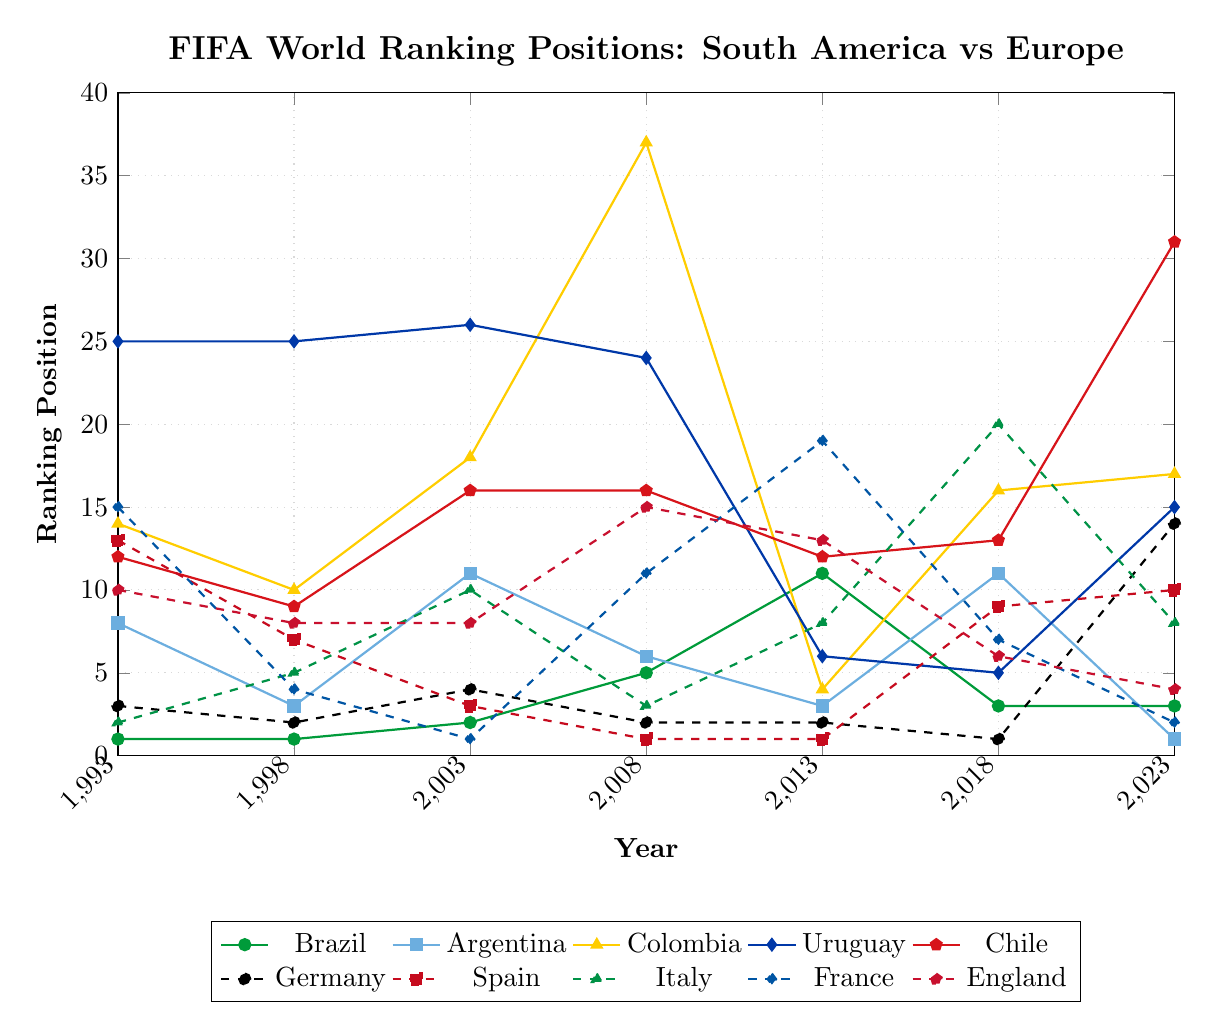Which South American team was ranked highest in 2013? From the figure, Argentina has the highest ranking among the South American teams in 2013, with a position of 3.
Answer: Argentina Which European team has shown the most fluctuation in rankings over the last 30 years? France has significant fluctuations, with rankings varying from a high of 1 in 2003 to a low of 19 in 2013 and back to 2 in 2023. This wide range indicates considerable fluctuation.
Answer: France What is the average ranking position for Brazil across the last 30 years? Adding up Brazil's rankings (1, 1, 2, 5, 11, 3, 3) and dividing by 7 years gives an average of (1+1+2+5+11+3+3)/7 = 26/7 ≈ 3.71.
Answer: Approximately 3.71 Compare the 1998 and 2013 rankings of Chile and Italy. How have their positions changed over time? In 1998, Chile was ranked 9 and Italy was ranked 5. In 2013, Chile was ranked 12 and Italy was ranked 8. Chile dropped by 3 positions (9 to 12), while Italy dropped by 3 positions (5 to 8).
Answer: Both dropped by 3 positions What is the median ranking position for European teams in 2018? The European teams' rankings in 2018 are 1 (Germany), 9 (Spain), 20 (Italy), 7 (France), and 6 (England). Ordering them gives [1, 6, 7, 9, 20]. The median is the third value, which is 7.
Answer: 7 Which country had the highest rank in the year 2003 and what was it? From the figure, France had the highest rank in 2003 with a position of 1.
Answer: France, 1 In which year did Uruguay achieve its highest FIFA ranking and what was the rank? Uruguay achieved its highest ranking in 2013 with a position of 6.
Answer: 2013, 6 How did Germany's ranking position change from 2013 to 2023? Germany's ranking changed from 2 in 2013 to 14 in 2023, dropping by 12 positions.
Answer: Dropped by 12 positions Between Brazil and Argentina, which team has more consistently high rankings over the years? Brazil's rankings are 1, 1, 2, 5, 11, 3, 3 indicating more consistency in staying within top positions compared to Argentina's 8, 3, 11, 6, 3, 11, 1. Argentina's range is wider.
Answer: Brazil 